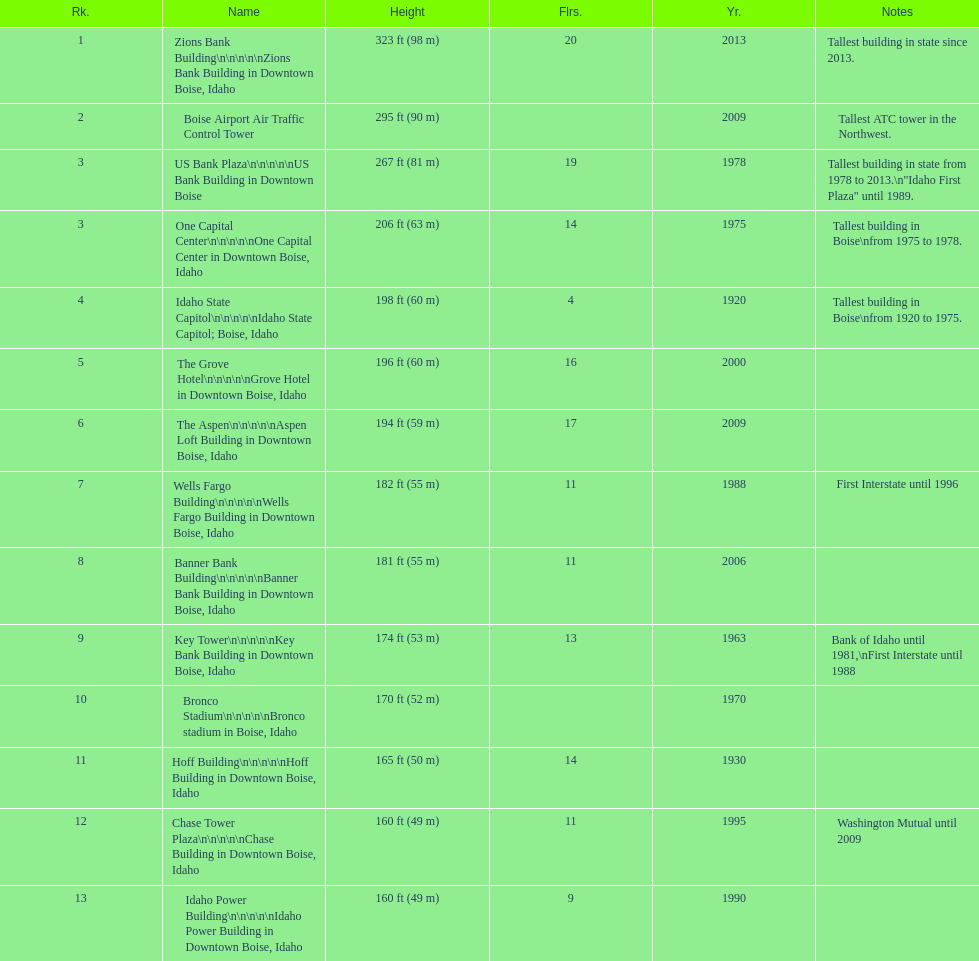Would you be able to parse every entry in this table? {'header': ['Rk.', 'Name', 'Height', 'Flrs.', 'Yr.', 'Notes'], 'rows': [['1', 'Zions Bank Building\\n\\n\\n\\n\\nZions Bank Building in Downtown Boise, Idaho', '323\xa0ft (98\xa0m)', '20', '2013', 'Tallest building in state since 2013.'], ['2', 'Boise Airport Air Traffic Control Tower', '295\xa0ft (90\xa0m)', '', '2009', 'Tallest ATC tower in the Northwest.'], ['3', 'US Bank Plaza\\n\\n\\n\\n\\nUS Bank Building in Downtown Boise', '267\xa0ft (81\xa0m)', '19', '1978', 'Tallest building in state from 1978 to 2013.\\n"Idaho First Plaza" until 1989.'], ['3', 'One Capital Center\\n\\n\\n\\n\\nOne Capital Center in Downtown Boise, Idaho', '206\xa0ft (63\xa0m)', '14', '1975', 'Tallest building in Boise\\nfrom 1975 to 1978.'], ['4', 'Idaho State Capitol\\n\\n\\n\\n\\nIdaho State Capitol; Boise, Idaho', '198\xa0ft (60\xa0m)', '4', '1920', 'Tallest building in Boise\\nfrom 1920 to 1975.'], ['5', 'The Grove Hotel\\n\\n\\n\\n\\nGrove Hotel in Downtown Boise, Idaho', '196\xa0ft (60\xa0m)', '16', '2000', ''], ['6', 'The Aspen\\n\\n\\n\\n\\nAspen Loft Building in Downtown Boise, Idaho', '194\xa0ft (59\xa0m)', '17', '2009', ''], ['7', 'Wells Fargo Building\\n\\n\\n\\n\\nWells Fargo Building in Downtown Boise, Idaho', '182\xa0ft (55\xa0m)', '11', '1988', 'First Interstate until 1996'], ['8', 'Banner Bank Building\\n\\n\\n\\n\\nBanner Bank Building in Downtown Boise, Idaho', '181\xa0ft (55\xa0m)', '11', '2006', ''], ['9', 'Key Tower\\n\\n\\n\\n\\nKey Bank Building in Downtown Boise, Idaho', '174\xa0ft (53\xa0m)', '13', '1963', 'Bank of Idaho until 1981,\\nFirst Interstate until 1988'], ['10', 'Bronco Stadium\\n\\n\\n\\n\\nBronco stadium in Boise, Idaho', '170\xa0ft (52\xa0m)', '', '1970', ''], ['11', 'Hoff Building\\n\\n\\n\\n\\nHoff Building in Downtown Boise, Idaho', '165\xa0ft (50\xa0m)', '14', '1930', ''], ['12', 'Chase Tower Plaza\\n\\n\\n\\n\\nChase Building in Downtown Boise, Idaho', '160\xa0ft (49\xa0m)', '11', '1995', 'Washington Mutual until 2009'], ['13', 'Idaho Power Building\\n\\n\\n\\n\\nIdaho Power Building in Downtown Boise, Idaho', '160\xa0ft (49\xa0m)', '9', '1990', '']]} What is the name of the building listed after idaho state capitol? The Grove Hotel. 